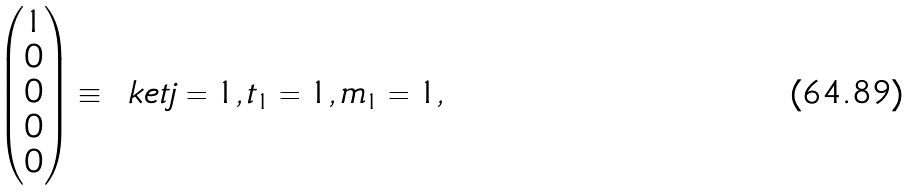<formula> <loc_0><loc_0><loc_500><loc_500>\begin{pmatrix} 1 \\ 0 \\ 0 \\ 0 \\ 0 \end{pmatrix} & \equiv \, \ k e t { j = 1 , t _ { 1 } = 1 , m _ { 1 } = 1 } ,</formula> 